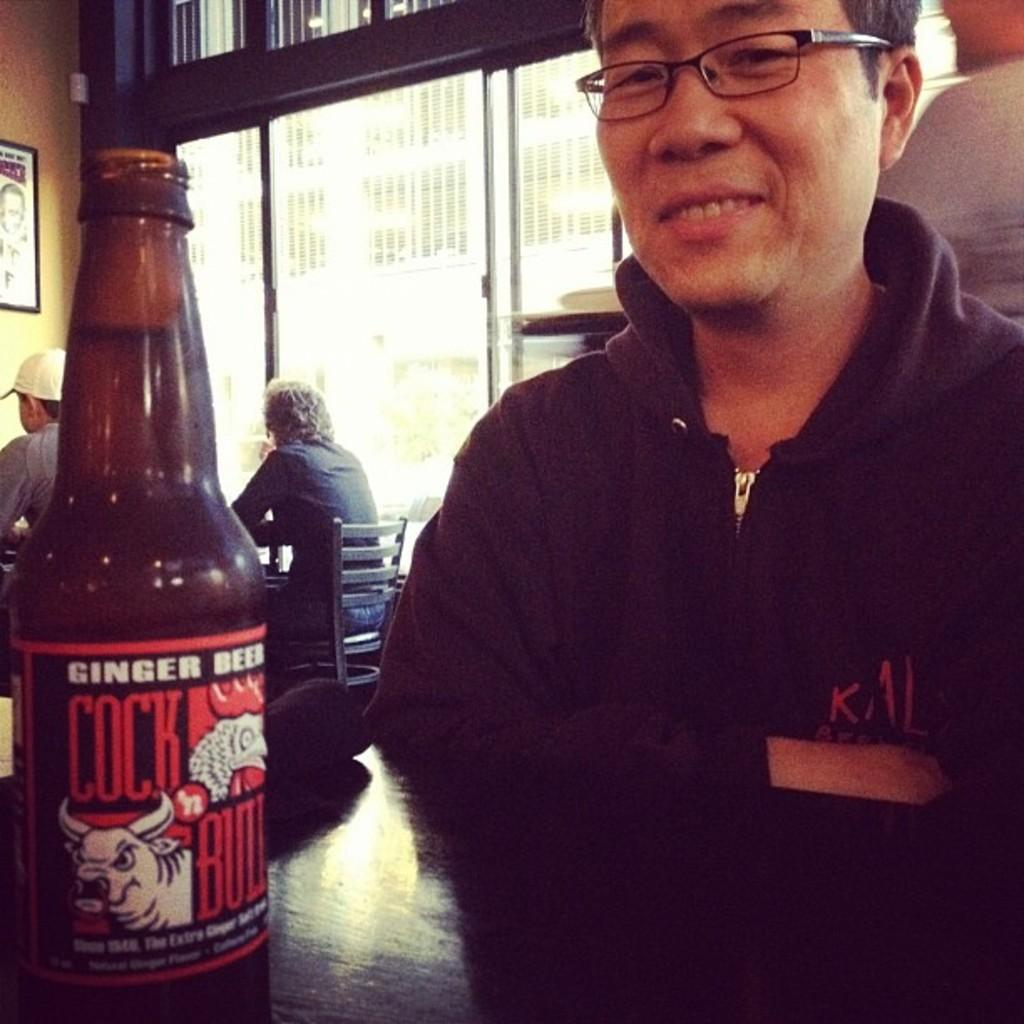What is the person in the image wearing? The person is wearing a black dress in the image. Where is the person sitting in relation to the table? The person is sitting in front of the table. What can be seen on the table in the image? There is a wine bottle on the table. How many other persons are sitting in the image? There are two other persons sitting behind the person in the black dress. What type of jelly is being used to style the person's hair in the image? There is no jelly present in the image, and the person's hair is not mentioned. 